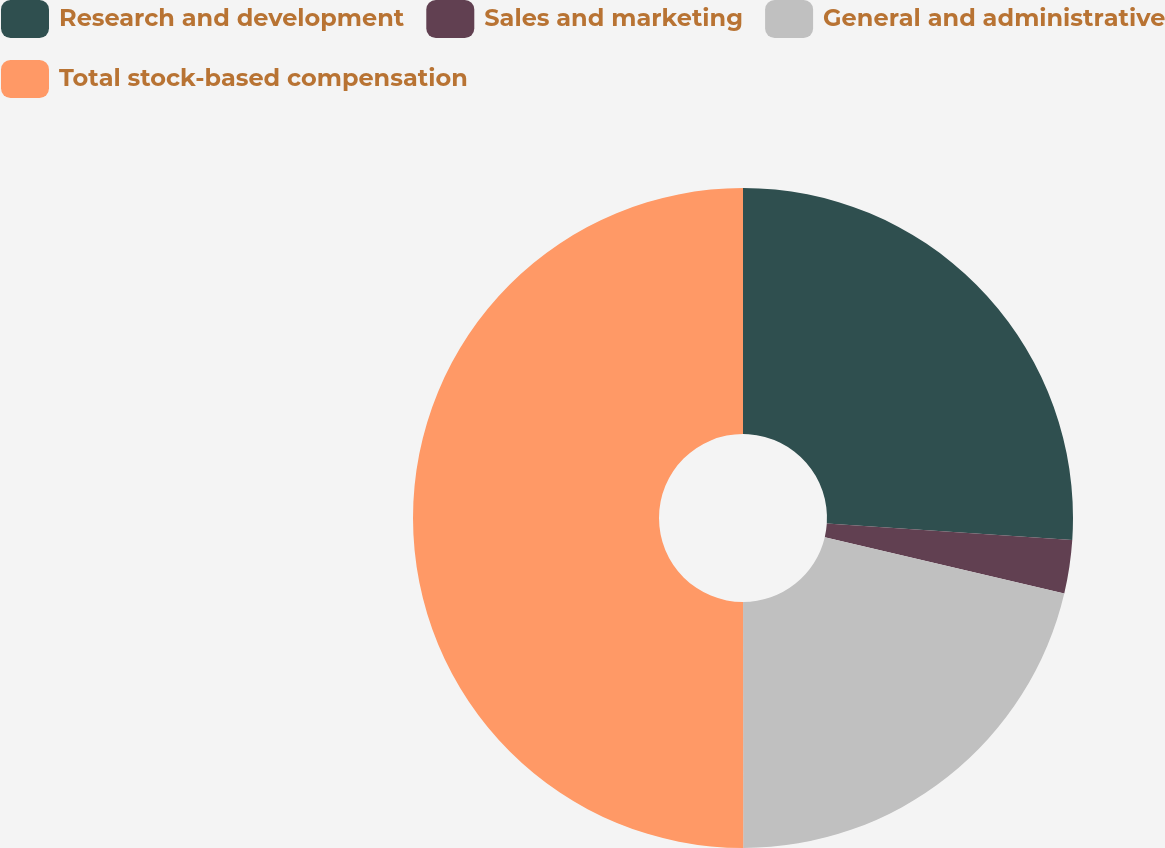<chart> <loc_0><loc_0><loc_500><loc_500><pie_chart><fcel>Research and development<fcel>Sales and marketing<fcel>General and administrative<fcel>Total stock-based compensation<nl><fcel>26.06%<fcel>2.61%<fcel>21.32%<fcel>50.01%<nl></chart> 